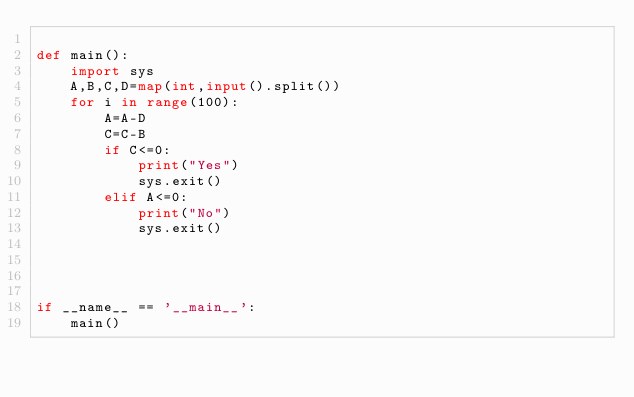Convert code to text. <code><loc_0><loc_0><loc_500><loc_500><_Python_>
def main():
    import sys
    A,B,C,D=map(int,input().split())
    for i in range(100):
        A=A-D
        C=C-B
        if C<=0:
            print("Yes")
            sys.exit()
        elif A<=0:
            print("No")
            sys.exit()
        

    

if __name__ == '__main__':
    main()</code> 